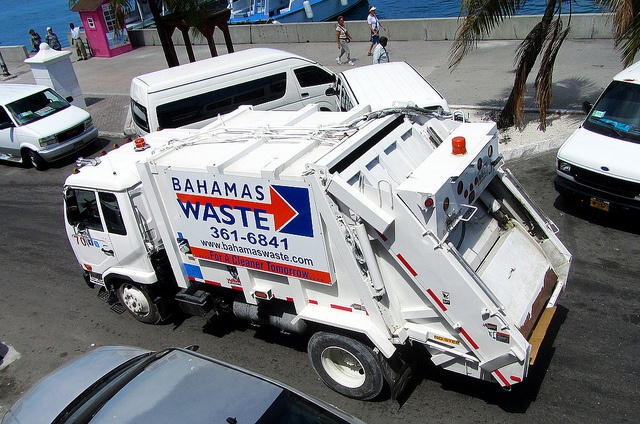Describe the objects in this image and their specific colors. I can see truck in blue, lightgray, black, gray, and darkgray tones, car in blue, darkgray, gray, and black tones, car in blue, lightgray, black, darkgray, and gray tones, car in blue, black, white, and navy tones, and car in blue, black, white, gray, and darkgray tones in this image. 